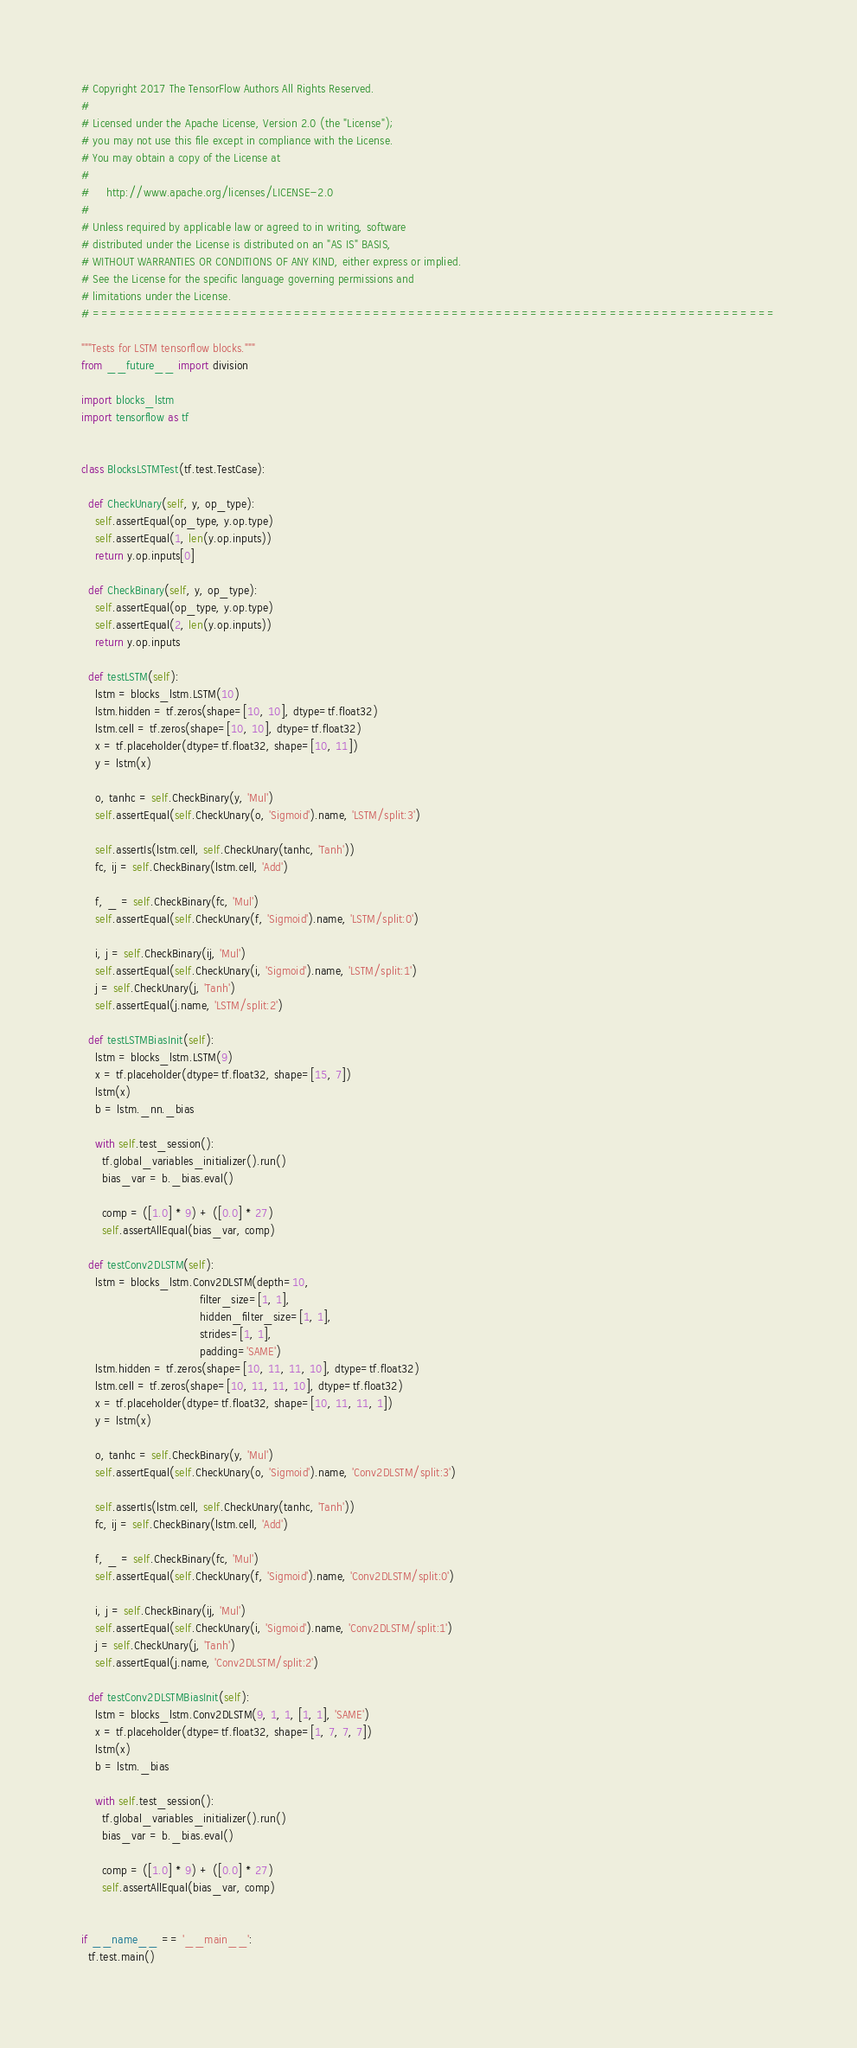Convert code to text. <code><loc_0><loc_0><loc_500><loc_500><_Python_># Copyright 2017 The TensorFlow Authors All Rights Reserved.
#
# Licensed under the Apache License, Version 2.0 (the "License");
# you may not use this file except in compliance with the License.
# You may obtain a copy of the License at
#
#     http://www.apache.org/licenses/LICENSE-2.0
#
# Unless required by applicable law or agreed to in writing, software
# distributed under the License is distributed on an "AS IS" BASIS,
# WITHOUT WARRANTIES OR CONDITIONS OF ANY KIND, either express or implied.
# See the License for the specific language governing permissions and
# limitations under the License.
# ==============================================================================

"""Tests for LSTM tensorflow blocks."""
from __future__ import division

import blocks_lstm
import tensorflow as tf


class BlocksLSTMTest(tf.test.TestCase):

  def CheckUnary(self, y, op_type):
    self.assertEqual(op_type, y.op.type)
    self.assertEqual(1, len(y.op.inputs))
    return y.op.inputs[0]

  def CheckBinary(self, y, op_type):
    self.assertEqual(op_type, y.op.type)
    self.assertEqual(2, len(y.op.inputs))
    return y.op.inputs

  def testLSTM(self):
    lstm = blocks_lstm.LSTM(10)
    lstm.hidden = tf.zeros(shape=[10, 10], dtype=tf.float32)
    lstm.cell = tf.zeros(shape=[10, 10], dtype=tf.float32)
    x = tf.placeholder(dtype=tf.float32, shape=[10, 11])
    y = lstm(x)

    o, tanhc = self.CheckBinary(y, 'Mul')
    self.assertEqual(self.CheckUnary(o, 'Sigmoid').name, 'LSTM/split:3')

    self.assertIs(lstm.cell, self.CheckUnary(tanhc, 'Tanh'))
    fc, ij = self.CheckBinary(lstm.cell, 'Add')

    f, _ = self.CheckBinary(fc, 'Mul')
    self.assertEqual(self.CheckUnary(f, 'Sigmoid').name, 'LSTM/split:0')

    i, j = self.CheckBinary(ij, 'Mul')
    self.assertEqual(self.CheckUnary(i, 'Sigmoid').name, 'LSTM/split:1')
    j = self.CheckUnary(j, 'Tanh')
    self.assertEqual(j.name, 'LSTM/split:2')

  def testLSTMBiasInit(self):
    lstm = blocks_lstm.LSTM(9)
    x = tf.placeholder(dtype=tf.float32, shape=[15, 7])
    lstm(x)
    b = lstm._nn._bias

    with self.test_session():
      tf.global_variables_initializer().run()
      bias_var = b._bias.eval()

      comp = ([1.0] * 9) + ([0.0] * 27)
      self.assertAllEqual(bias_var, comp)

  def testConv2DLSTM(self):
    lstm = blocks_lstm.Conv2DLSTM(depth=10,
                                  filter_size=[1, 1],
                                  hidden_filter_size=[1, 1],
                                  strides=[1, 1],
                                  padding='SAME')
    lstm.hidden = tf.zeros(shape=[10, 11, 11, 10], dtype=tf.float32)
    lstm.cell = tf.zeros(shape=[10, 11, 11, 10], dtype=tf.float32)
    x = tf.placeholder(dtype=tf.float32, shape=[10, 11, 11, 1])
    y = lstm(x)

    o, tanhc = self.CheckBinary(y, 'Mul')
    self.assertEqual(self.CheckUnary(o, 'Sigmoid').name, 'Conv2DLSTM/split:3')

    self.assertIs(lstm.cell, self.CheckUnary(tanhc, 'Tanh'))
    fc, ij = self.CheckBinary(lstm.cell, 'Add')

    f, _ = self.CheckBinary(fc, 'Mul')
    self.assertEqual(self.CheckUnary(f, 'Sigmoid').name, 'Conv2DLSTM/split:0')

    i, j = self.CheckBinary(ij, 'Mul')
    self.assertEqual(self.CheckUnary(i, 'Sigmoid').name, 'Conv2DLSTM/split:1')
    j = self.CheckUnary(j, 'Tanh')
    self.assertEqual(j.name, 'Conv2DLSTM/split:2')

  def testConv2DLSTMBiasInit(self):
    lstm = blocks_lstm.Conv2DLSTM(9, 1, 1, [1, 1], 'SAME')
    x = tf.placeholder(dtype=tf.float32, shape=[1, 7, 7, 7])
    lstm(x)
    b = lstm._bias

    with self.test_session():
      tf.global_variables_initializer().run()
      bias_var = b._bias.eval()

      comp = ([1.0] * 9) + ([0.0] * 27)
      self.assertAllEqual(bias_var, comp)


if __name__ == '__main__':
  tf.test.main()
</code> 